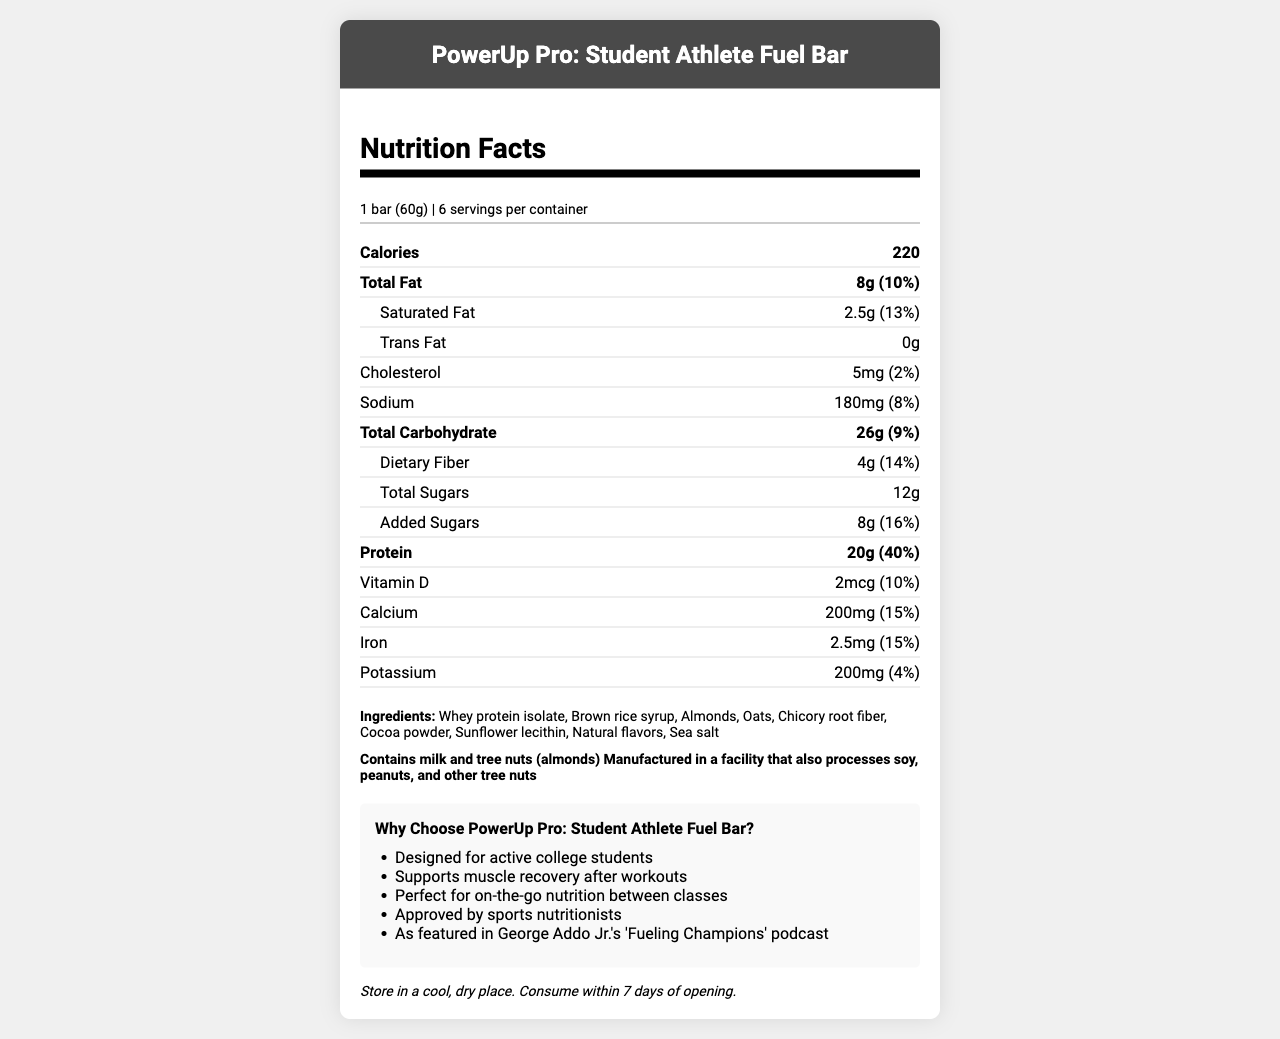who is the product designed for? The marketing claims section indicates that the product is "Designed for active college students."
Answer: Active college students what is the serving size of the product? The serving size is mentioned right under the Nutrition Facts header as "1 bar (60g)."
Answer: 1 bar (60g) how many calories are in one serving of the PowerUp Pro bar? The number of calories per serving is bolded and specified as 220.
Answer: 220 how much protein does the PowerUp Pro bar contain per serving? The protein content is listed as 20g with a daily value percentage of 40%.
Answer: 20g what is the percentage of daily value for dietary fiber? The daily value percentage for dietary fiber is listed directly after the amount, as 14%.
Answer: 14% which allergens are mentioned on the label? The allergens section states, "Contains milk and tree nuts (almonds)."
Answer: Milk and tree nuts (almonds) how much sodium is in one serving? The sodium content is indicated as 180mg with a daily value of 8%.
Answer: 180mg how much added sugar is in each bar? The amount of added sugars is shown as 8g with a daily value of 16%.
Answer: 8g what should you do after opening the package? The storage instructions recommend consuming the product within 7 days of opening.
Answer: Consume within 7 days of opening which ingredient is listed first? The ingredients section lists whey protein isolate as the first ingredient.
Answer: Whey protein isolate how many bars are in one container? The label specifies that there are 6 bars per container.
Answer: 6 which vitamin has a daily value of 10%? A. Vitamin D B. Calcium C. Iron D. Potassium The daily value for Vitamin D is listed as 10%, which matches option A.
Answer: A what is the main theme of the marketing claims section? The marketing claims highlight that the product is meant for active college students and helps with muscle recovery, among other benefits.
Answer: The bar is designed for active college students and supports muscle recovery are there trans fats in the PowerUp Pro bar? The trans fat content is listed as 0g, indicating there are no trans fats.
Answer: No does the document mention soy as an allergen? The allergens section does not list soy as a direct allergen; however, it states that the product is manufactured in a facility that processes soy.
Answer: No, but it notes potential cross-contamination how much iron does each bar provide? The iron content per serving is listed as 2.5mg with a daily value of 15%.
Answer: 2.5mg how many servings are provided per container? A. 4 B. 6 C. 8 D. 10 The servings per container are listed as 6 servings.
Answer: B how much saturated fat is in each bar? The saturated fat content is listed as 2.5g with a daily value of 13%.
Answer: 2.5g how much calcium is in one serving of the bar? The calcium content per serving is listed as 200mg with a daily value of 15%.
Answer: 200mg does the product contain gluten? The document does not provide explicit information about the presence or absence of gluten.
Answer: Not enough information summarize the document in one sentence. The document contains comprehensive information about the product including serving size, nutritional values, ingredients, allergens, marketing claims directed at college students, and storage instructions.
Answer: The document is a Nutrition Facts Label for the "PowerUp Pro: Student Athlete Fuel Bar," detailing its nutritional content, ingredients, allergens, marketing claims, and storage instructions. 